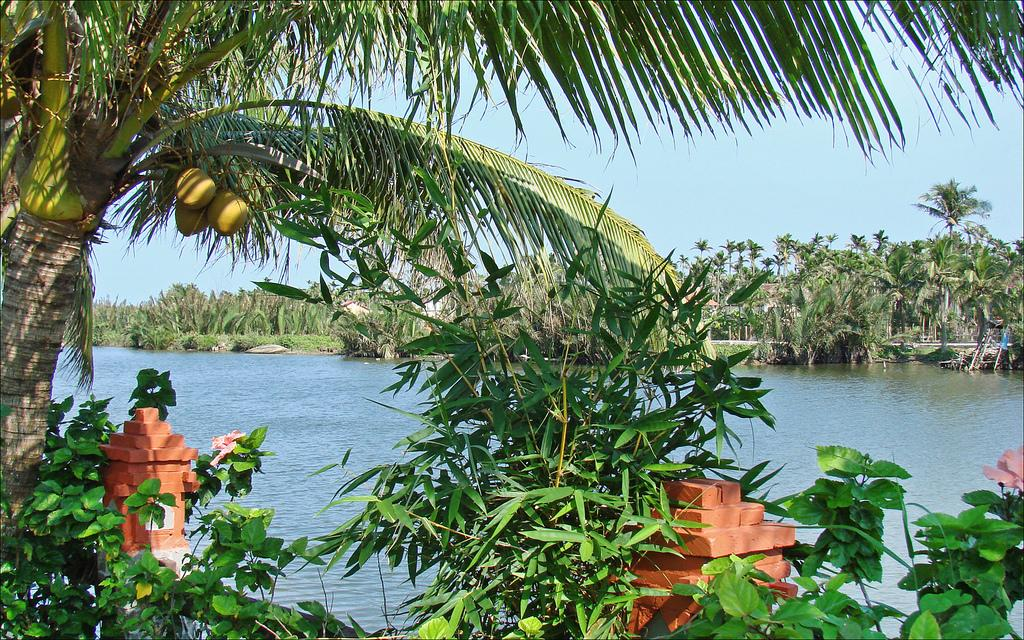What is the primary element in the image? There is water in the image. What type of vegetation can be seen in the image? There are trees in the image. What objects are associated with the trees in the image? Coconuts are present in the image. What type of building material is visible in the image? Bricks are visible in the image. What can be seen in the background of the image? The sky is visible in the background of the image. What type of brass instrument is being played in the image? There is no brass instrument present in the image. How many potatoes are visible in the image? There are no potatoes visible in the image. 